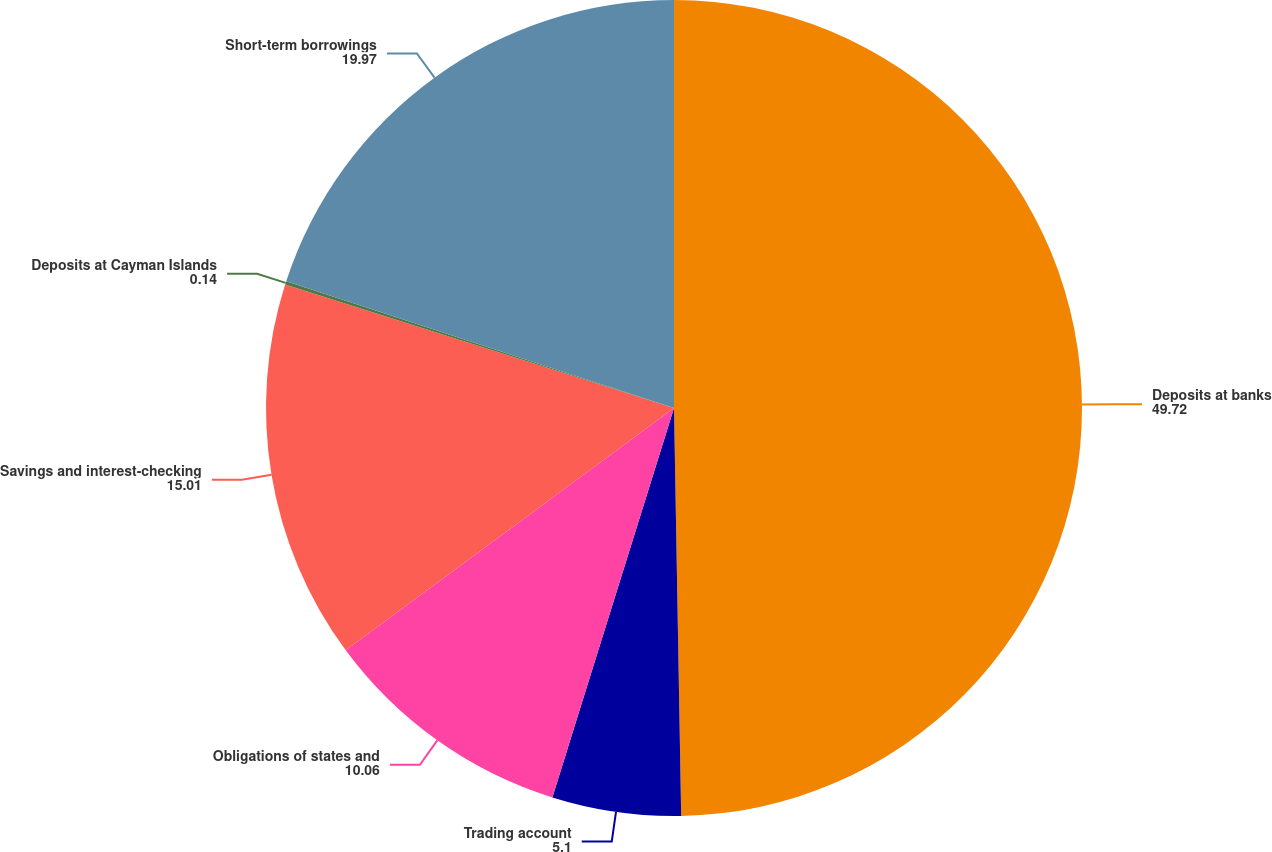Convert chart. <chart><loc_0><loc_0><loc_500><loc_500><pie_chart><fcel>Deposits at banks<fcel>Trading account<fcel>Obligations of states and<fcel>Savings and interest-checking<fcel>Deposits at Cayman Islands<fcel>Short-term borrowings<nl><fcel>49.72%<fcel>5.1%<fcel>10.06%<fcel>15.01%<fcel>0.14%<fcel>19.97%<nl></chart> 